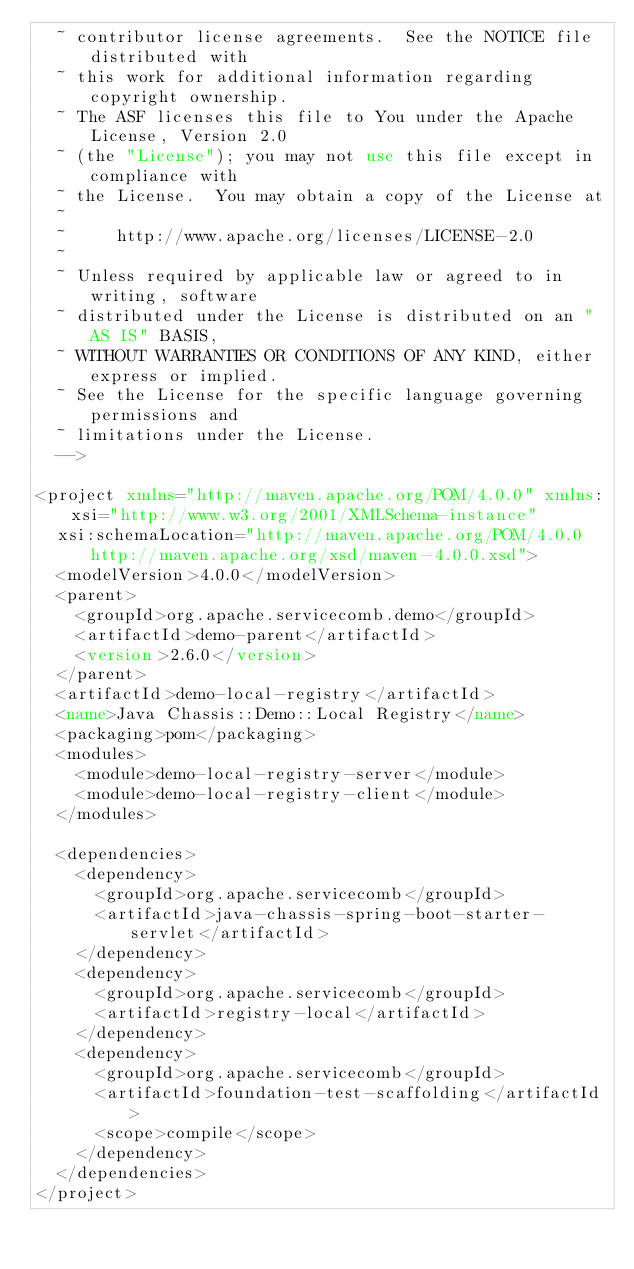Convert code to text. <code><loc_0><loc_0><loc_500><loc_500><_XML_>  ~ contributor license agreements.  See the NOTICE file distributed with
  ~ this work for additional information regarding copyright ownership.
  ~ The ASF licenses this file to You under the Apache License, Version 2.0
  ~ (the "License"); you may not use this file except in compliance with
  ~ the License.  You may obtain a copy of the License at
  ~
  ~     http://www.apache.org/licenses/LICENSE-2.0
  ~
  ~ Unless required by applicable law or agreed to in writing, software
  ~ distributed under the License is distributed on an "AS IS" BASIS,
  ~ WITHOUT WARRANTIES OR CONDITIONS OF ANY KIND, either express or implied.
  ~ See the License for the specific language governing permissions and
  ~ limitations under the License.
  -->

<project xmlns="http://maven.apache.org/POM/4.0.0" xmlns:xsi="http://www.w3.org/2001/XMLSchema-instance"
  xsi:schemaLocation="http://maven.apache.org/POM/4.0.0 http://maven.apache.org/xsd/maven-4.0.0.xsd">
  <modelVersion>4.0.0</modelVersion>
  <parent>
    <groupId>org.apache.servicecomb.demo</groupId>
    <artifactId>demo-parent</artifactId>
    <version>2.6.0</version>
  </parent>
  <artifactId>demo-local-registry</artifactId>
  <name>Java Chassis::Demo::Local Registry</name>
  <packaging>pom</packaging>
  <modules>
    <module>demo-local-registry-server</module>
    <module>demo-local-registry-client</module>
  </modules>

  <dependencies>
    <dependency>
      <groupId>org.apache.servicecomb</groupId>
      <artifactId>java-chassis-spring-boot-starter-servlet</artifactId>
    </dependency>
    <dependency>
      <groupId>org.apache.servicecomb</groupId>
      <artifactId>registry-local</artifactId>
    </dependency>
    <dependency>
      <groupId>org.apache.servicecomb</groupId>
      <artifactId>foundation-test-scaffolding</artifactId>
      <scope>compile</scope>
    </dependency>
  </dependencies>
</project>
</code> 